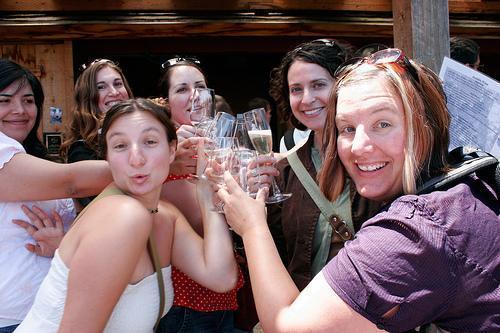How many women are in this photo?
Give a very brief answer. 6. How many women have glasses on their heads?
Give a very brief answer. 4. 